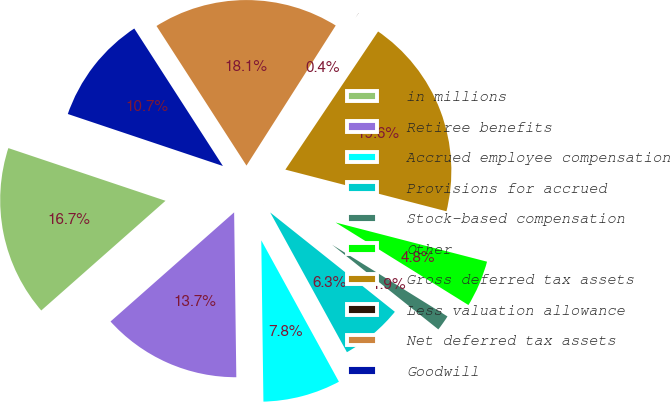Convert chart to OTSL. <chart><loc_0><loc_0><loc_500><loc_500><pie_chart><fcel>in millions<fcel>Retiree benefits<fcel>Accrued employee compensation<fcel>Provisions for accrued<fcel>Stock-based compensation<fcel>Other<fcel>Gross deferred tax assets<fcel>Less valuation allowance<fcel>Net deferred tax assets<fcel>Goodwill<nl><fcel>16.66%<fcel>13.7%<fcel>7.78%<fcel>6.3%<fcel>1.86%<fcel>4.82%<fcel>19.62%<fcel>0.38%<fcel>18.14%<fcel>10.74%<nl></chart> 